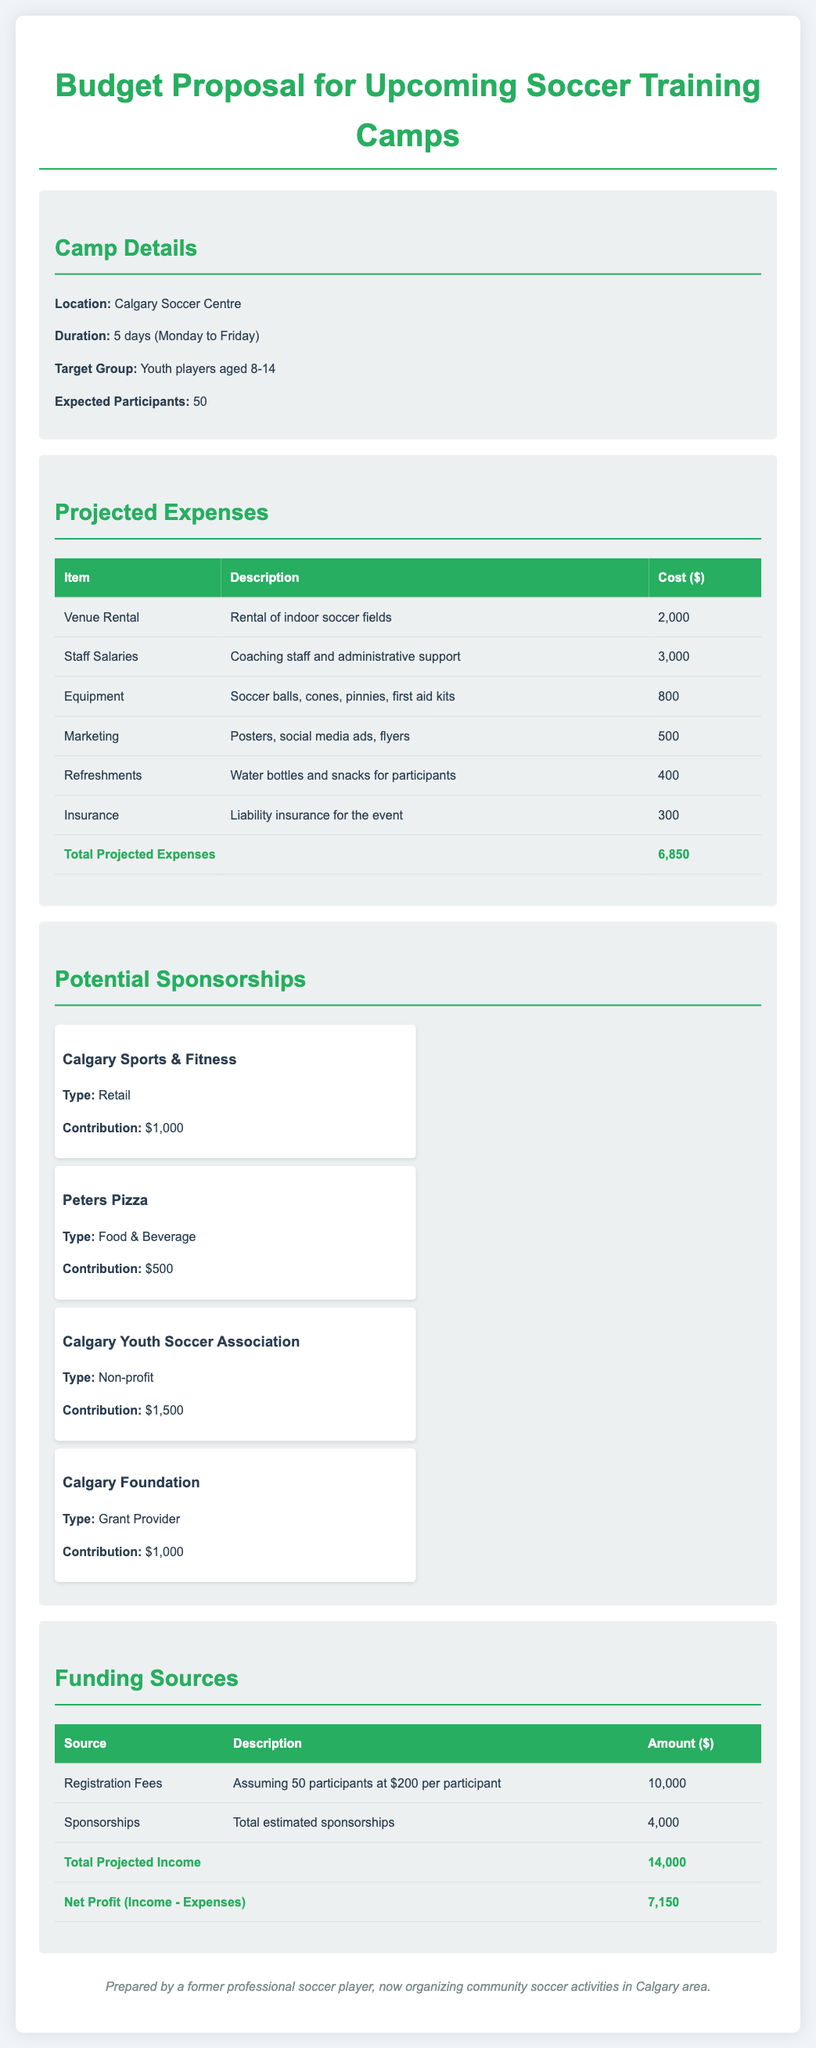What is the location of the camp? The location of the camp is specified in the camp details section of the document.
Answer: Calgary Soccer Centre What is the total projected expenses? The total projected expenses can be found in the expenses table, which sums the individual costs listed.
Answer: 6,850 How many days will the camp last? The duration of the camp is mentioned in the camp details section, stating how many days it will be held.
Answer: 5 days What is the expected number of participants? The expected participants are indicated in the camp details section of the document.
Answer: 50 What is Calgary Youth Soccer Association's contribution? The contribution from the Calgary Youth Soccer Association is listed under potential sponsorships in the document.
Answer: 1,500 What is the net profit? The net profit is calculated by subtracting total projected expenses from total projected income, as detailed in the funding section of the document.
Answer: 7,150 What type of organization is Peters Pizza? The type of organization for Peters Pizza is mentioned in the potential sponsorships section.
Answer: Food & Beverage What is the cost for equipment? The cost for equipment is listed in the projected expenses table, detailing the specific item and its cost.
Answer: 800 What are the registration fees based on? The basis for registration fees is outlined in the funding sources section, indicating how the fees are calculated.
Answer: 50 participants at $200 per participant 